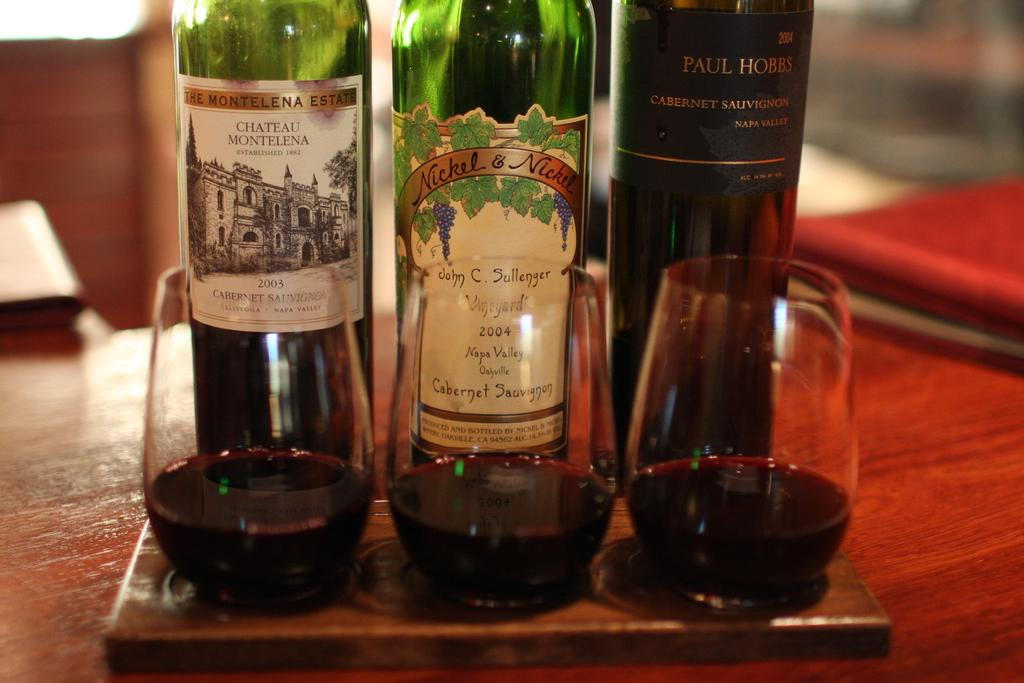<image>
Offer a succinct explanation of the picture presented. Wine bottle from the year 2004 behind three cups. 